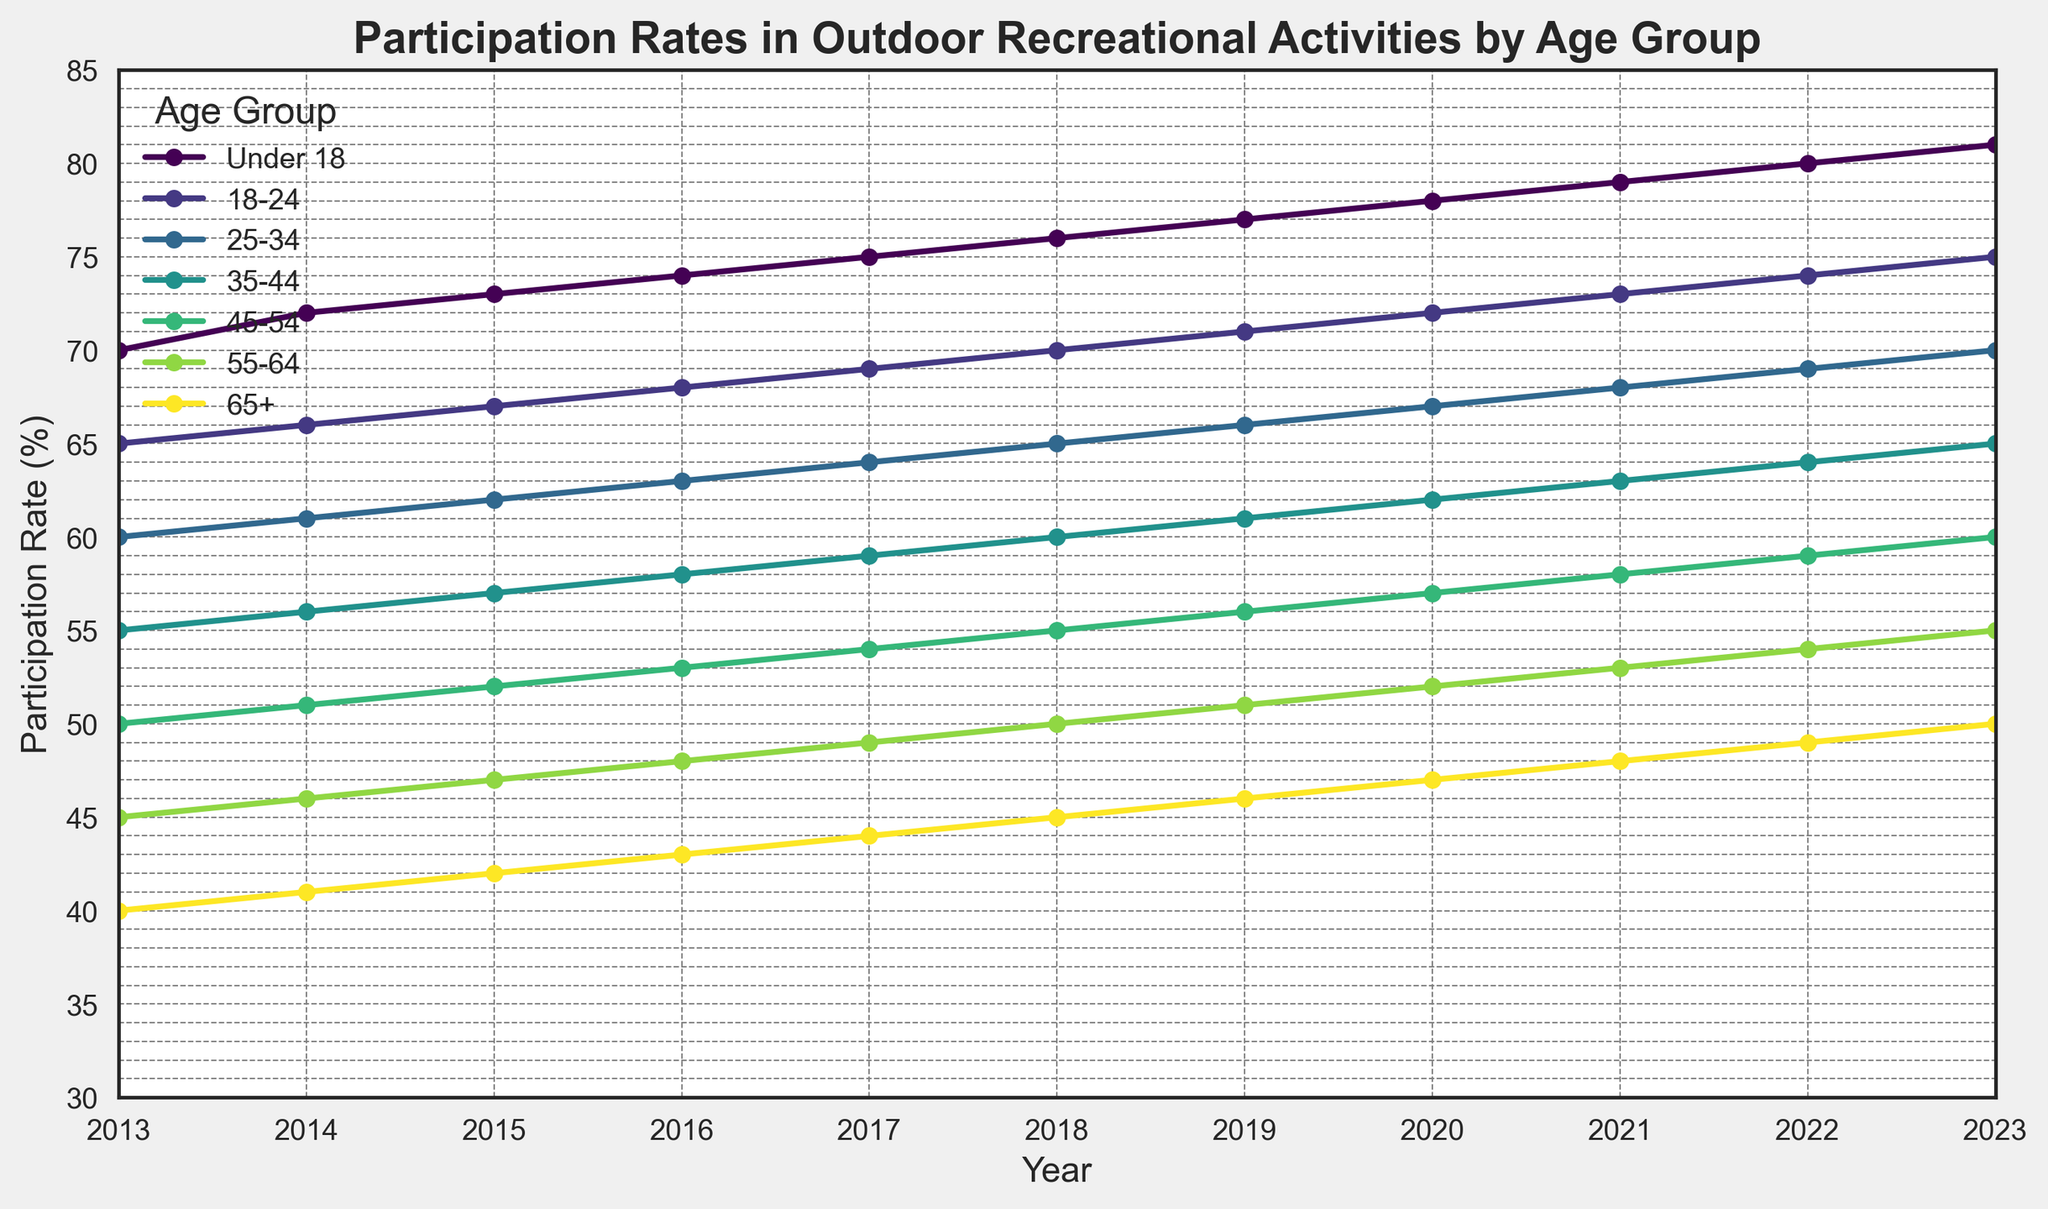Which year had the highest participation rate for the 18-24 age group? By examining the plot, we can follow the line representing the 18-24 age group and determine the peak value. The peak participation rate for this age group occurs in 2023.
Answer: 2023 How much did the participation rate for the 55-64 age group increase from 2013 to 2023? To find the increase, subtract the 2013 rate from the 2023 rate for the 55-64 age group: 2023 rate (55%) - 2013 rate (45%) = 10%.
Answer: 10% Which age group had the smallest increase in participation rates over the decade? By comparing the increasing trends of all the age groups, we see that the 65+ age group's line is the least steep. The increase for the 65+ age group from 2013 to 2023 is 50% - 40% = 10%.
Answer: 65+ What is the average participation rate for the 25-34 age group over the decade? Sum the participation rates from 2013 to 2023 for the 25-34 age group, then divide by the number of years: (60 + 61 + 62 + 63 + 64 + 65 + 66 + 67 + 68 + 69 + 70) / 11 = 65%.
Answer: 65% Compare the participation rates of the Under 18 and 45-54 age groups in 2016. Which is higher and by how much? In 2016, the Under 18 age group has a rate of 74%, while the 45-54 age group has 53%. The difference is 74% - 53% = 21%.
Answer: Under 18 by 21% Did any age group experience a year with a decrease in participation rates? We examine each age group's trend over time, noting that every age group's participation rate consistently increased without any decreases in any particular year.
Answer: No Which age group had a participation rate closest to 50% in 2019? By looking at the rates in 2019, the 45-54 age group had a 56% rate, which is the closest to 50% compared to other age groups.
Answer: 45-54 How many age groups had a participation rate of 70% or higher in 2022? By checking the 2022 participation rates, the Under 18 (80%), 18-24 (74%), and 25-34 (69%) groups participated at rates of 70% or higher. The 25-34 group falls short. So, two groups reach 70% or higher.
Answer: 2 In which year did the 35-44 age group cross the 60% participation rate? By following the line, the 35-44 age group crosses the 60% threshold in the year 2018.
Answer: 2018 Is the participation rate trend for all age groups linear? Observing the plot, the trends for all age groups show consistent linear growth over the years from 2013 to 2023.
Answer: Yes 